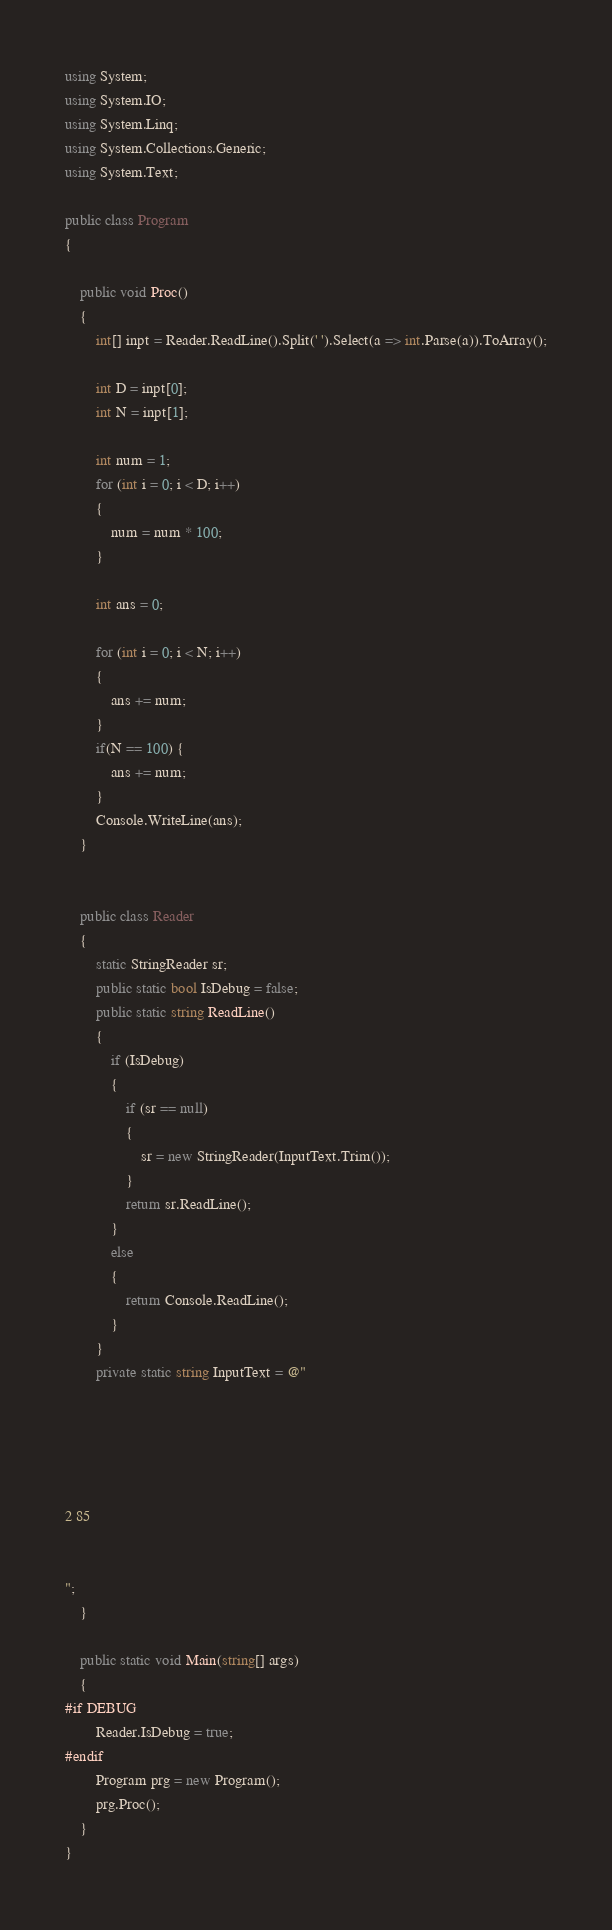<code> <loc_0><loc_0><loc_500><loc_500><_C#_>using System;
using System.IO;
using System.Linq;
using System.Collections.Generic;
using System.Text;

public class Program
{

    public void Proc()
    {
        int[] inpt = Reader.ReadLine().Split(' ').Select(a => int.Parse(a)).ToArray();

        int D = inpt[0];
        int N = inpt[1];

        int num = 1;
        for (int i = 0; i < D; i++)
        {
            num = num * 100;
        }

        int ans = 0;

        for (int i = 0; i < N; i++)
        {
            ans += num;
        }
        if(N == 100) {
            ans += num;
        }
        Console.WriteLine(ans);
    }


    public class Reader
    {
        static StringReader sr;
        public static bool IsDebug = false;
        public static string ReadLine()
        {
            if (IsDebug)
            {
                if (sr == null)
                {
                    sr = new StringReader(InputText.Trim());
                }
                return sr.ReadLine();
            }
            else
            {
                return Console.ReadLine();
            }
        }
        private static string InputText = @"
 
 
 
 
 
2 85
 
 
";
    }

    public static void Main(string[] args)
    {
#if DEBUG
        Reader.IsDebug = true;
#endif
        Program prg = new Program();
        prg.Proc();
    }
}
</code> 